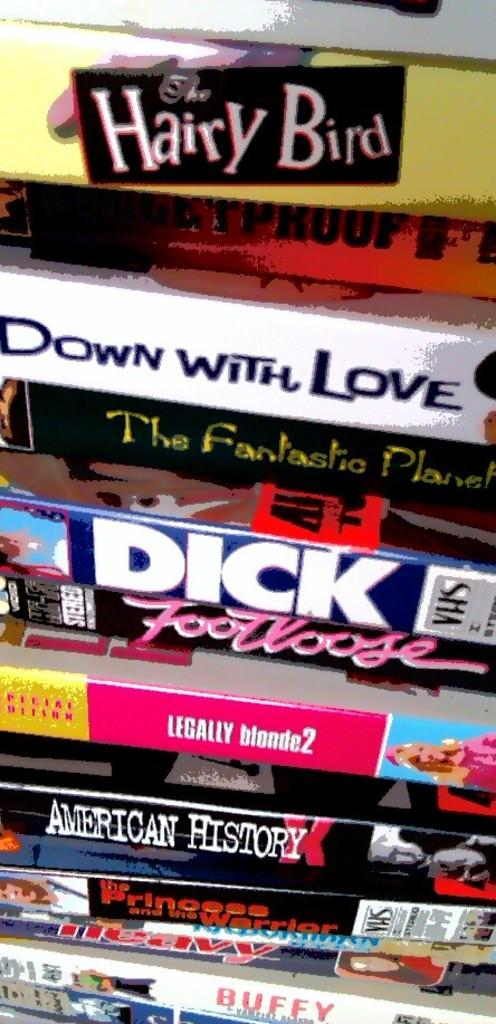<image>
Share a concise interpretation of the image provided. A bunch of movies stacked on top of each other, including Down with Love, Dick, and American History X. 